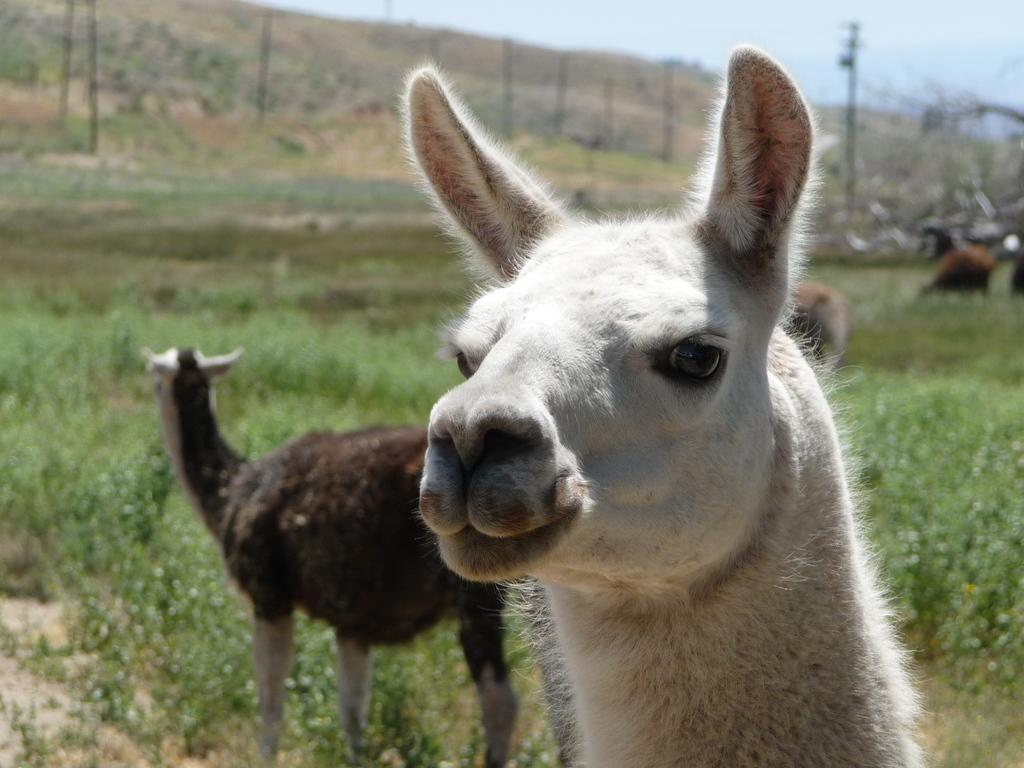Where was the image taken? The image was clicked outside. What can be seen in the middle of the image? There are animals in the middle of the image. What type of vegetation is present in the image? There are plants in the image. What is at the bottom of the image? There is grass at the bottom of the image. What is visible at the top of the image? The sky is visible at the top of the image. What type of texture can be seen on the bikes in the image? There are no bikes present in the image, so there is no texture to describe. 